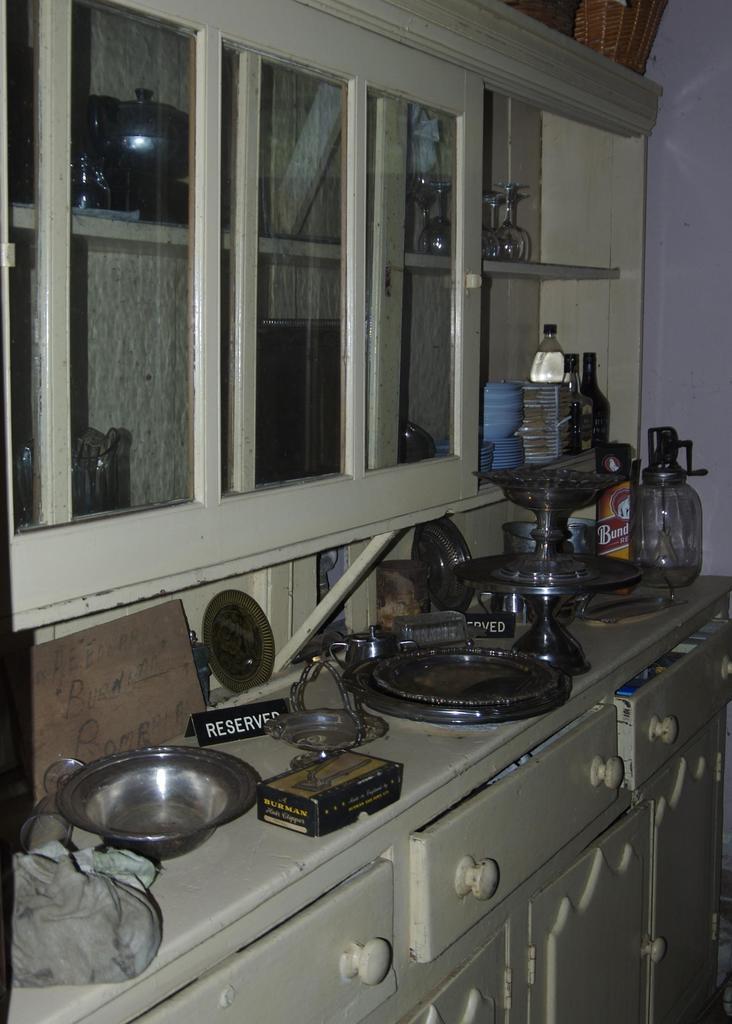What does the black sign say on the counter?
Offer a terse response. Reserved. What does the yellow letters say on the box?
Your response must be concise. Burman. 